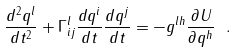<formula> <loc_0><loc_0><loc_500><loc_500>\frac { d ^ { 2 } q ^ { l } } { d t ^ { 2 } } + \Gamma _ { i j } ^ { l } \frac { d q ^ { i } } { d t } \frac { d q ^ { j } } { d t } = - g ^ { l h } \frac { \partial U } { \partial q ^ { h } } \ .</formula> 